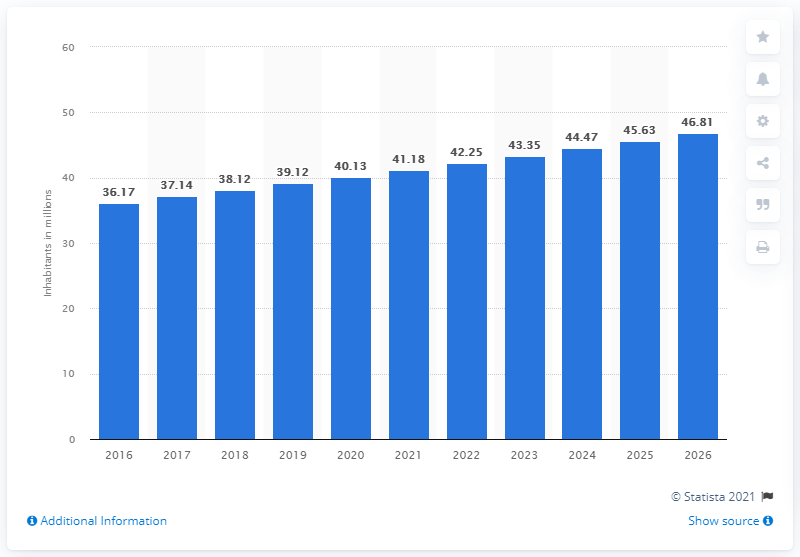What was the population of Iraq in 2020? In 2020, the population of Iraq was approximately 40.13 million, according to the data depicted in the bar chart. This reveals a continued upward trend in the population size over the past years, with an increase from the previous year's figure of 39.12 million in 2019. 